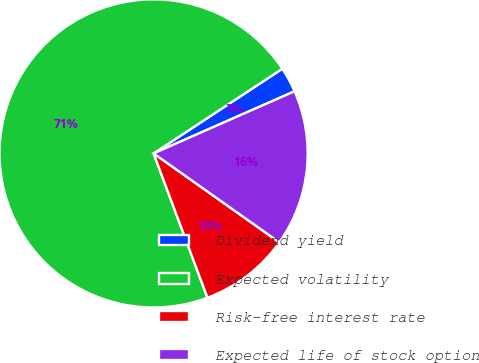Convert chart. <chart><loc_0><loc_0><loc_500><loc_500><pie_chart><fcel>Dividend yield<fcel>Expected volatility<fcel>Risk-free interest rate<fcel>Expected life of stock option<nl><fcel>2.65%<fcel>71.43%<fcel>9.52%<fcel>16.4%<nl></chart> 